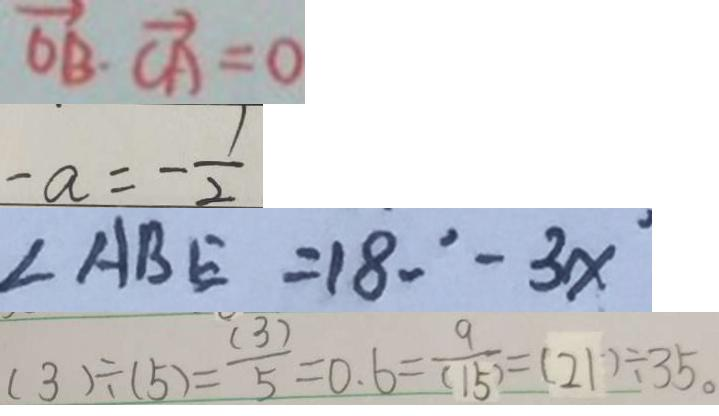<formula> <loc_0><loc_0><loc_500><loc_500>\overrightarrow { O B } \cdot \overrightarrow { C A } = 0 
 - a = - \frac { 1 } { 2 } 
 \angle A B E = 1 8 0 ^ { \circ } - 3 x ^ { \circ } 
 ( 3 ) \div ( 5 ) = \frac { ( 3 ) } { 5 } = 0 . 6 = \frac { 9 } { ( 1 5 ) } = ( 2 1 ) \div 3 5 。</formula> 